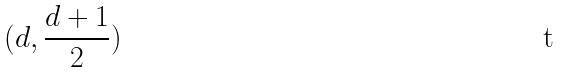Convert formula to latex. <formula><loc_0><loc_0><loc_500><loc_500>( d , \frac { d + 1 } { 2 } )</formula> 